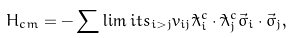Convert formula to latex. <formula><loc_0><loc_0><loc_500><loc_500>H _ { c m } = - \sum \lim i t s _ { i > j } v _ { i j } \tilde { \lambda } _ { i } ^ { c } \cdot \tilde { \lambda } _ { j } ^ { c } \vec { \sigma } _ { i } \cdot \vec { \sigma } _ { j } ,</formula> 